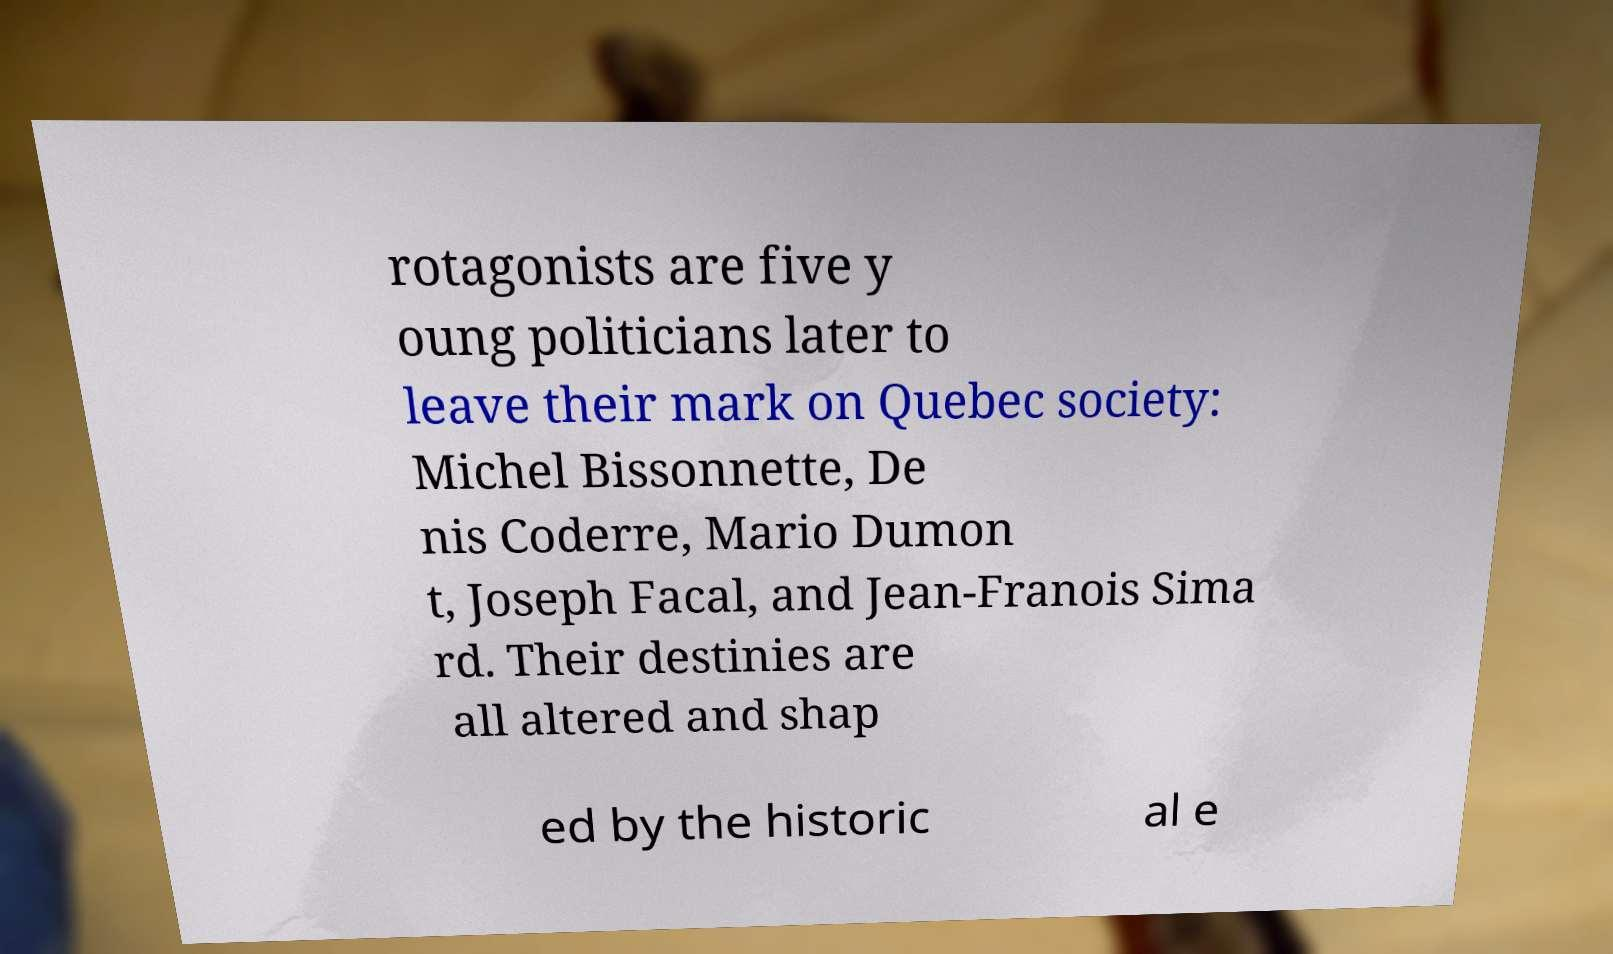Please read and relay the text visible in this image. What does it say? rotagonists are five y oung politicians later to leave their mark on Quebec society: Michel Bissonnette, De nis Coderre, Mario Dumon t, Joseph Facal, and Jean-Franois Sima rd. Their destinies are all altered and shap ed by the historic al e 